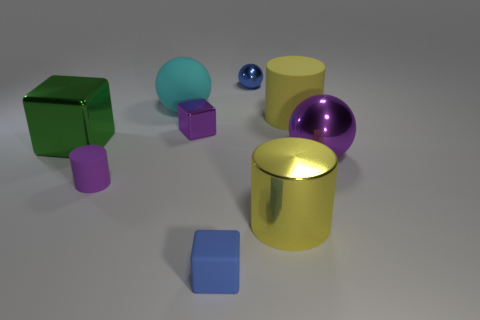Are there fewer large gray metallic spheres than metallic spheres?
Keep it short and to the point. Yes. How many matte objects are either large cylinders or tiny gray blocks?
Ensure brevity in your answer.  1. There is a large green cube that is to the left of the tiny purple matte cylinder; is there a small sphere that is on the left side of it?
Your answer should be very brief. No. Are the tiny block behind the large purple sphere and the large purple object made of the same material?
Your answer should be very brief. Yes. How many other things are the same color as the big metal block?
Provide a succinct answer. 0. Is the color of the small metallic cube the same as the big metal sphere?
Ensure brevity in your answer.  Yes. What size is the purple metal object that is left of the small ball behind the big yellow metallic thing?
Offer a terse response. Small. Do the yellow cylinder behind the large purple sphere and the small blue object in front of the tiny purple cube have the same material?
Ensure brevity in your answer.  Yes. There is a rubber thing that is right of the small blue cube; does it have the same color as the metal cylinder?
Make the answer very short. Yes. What number of metal objects are to the right of the yellow metal cylinder?
Give a very brief answer. 1. 